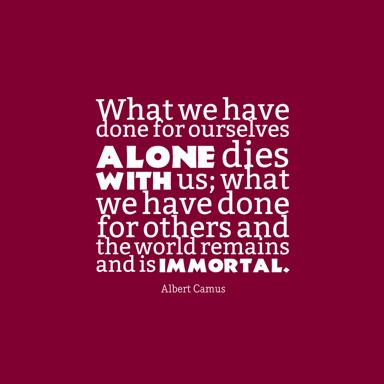What might be the reason for choosing a minimalist design for this quote? The minimalist design likely aims to ensure that the focus remains solely on the powerful message of the quote. By avoiding elaborate designs or distractions, the simplicity allows Albert Camus' poignant words to resonate more deeply with viewers, emphasizing clarity and the profound truth of the message. 